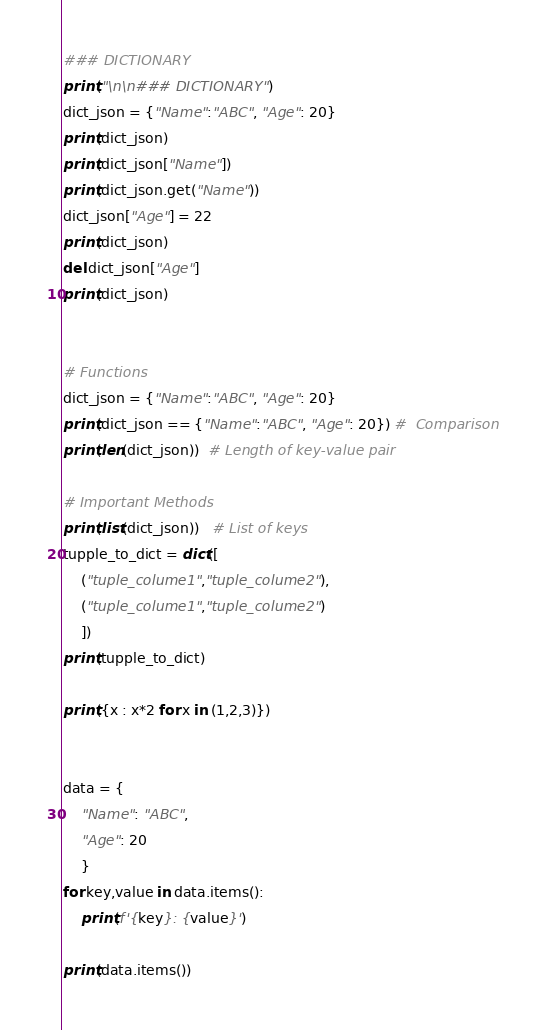<code> <loc_0><loc_0><loc_500><loc_500><_Python_>### DICTIONARY
print("\n\n### DICTIONARY")
dict_json = {"Name":"ABC", "Age": 20}
print(dict_json)
print(dict_json["Name"])
print(dict_json.get("Name"))
dict_json["Age"] = 22
print(dict_json)
del dict_json["Age"]
print(dict_json)


# Functions
dict_json = {"Name":"ABC", "Age": 20}
print(dict_json == {"Name":"ABC", "Age": 20}) #  Comparison
print(len(dict_json))  # Length of key-value pair

# Important Methods
print(list(dict_json))   # List of keys
tupple_to_dict = dict([
    ("tuple_colume1","tuple_colume2"), 
    ("tuple_colume1","tuple_colume2")
    ])
print(tupple_to_dict)

print({x : x*2 for x in (1,2,3)})


data = {
    "Name": "ABC",
    "Age": 20
    }
for key,value in data.items():
    print(f'{key}: {value}')
    
print(data.items())</code> 